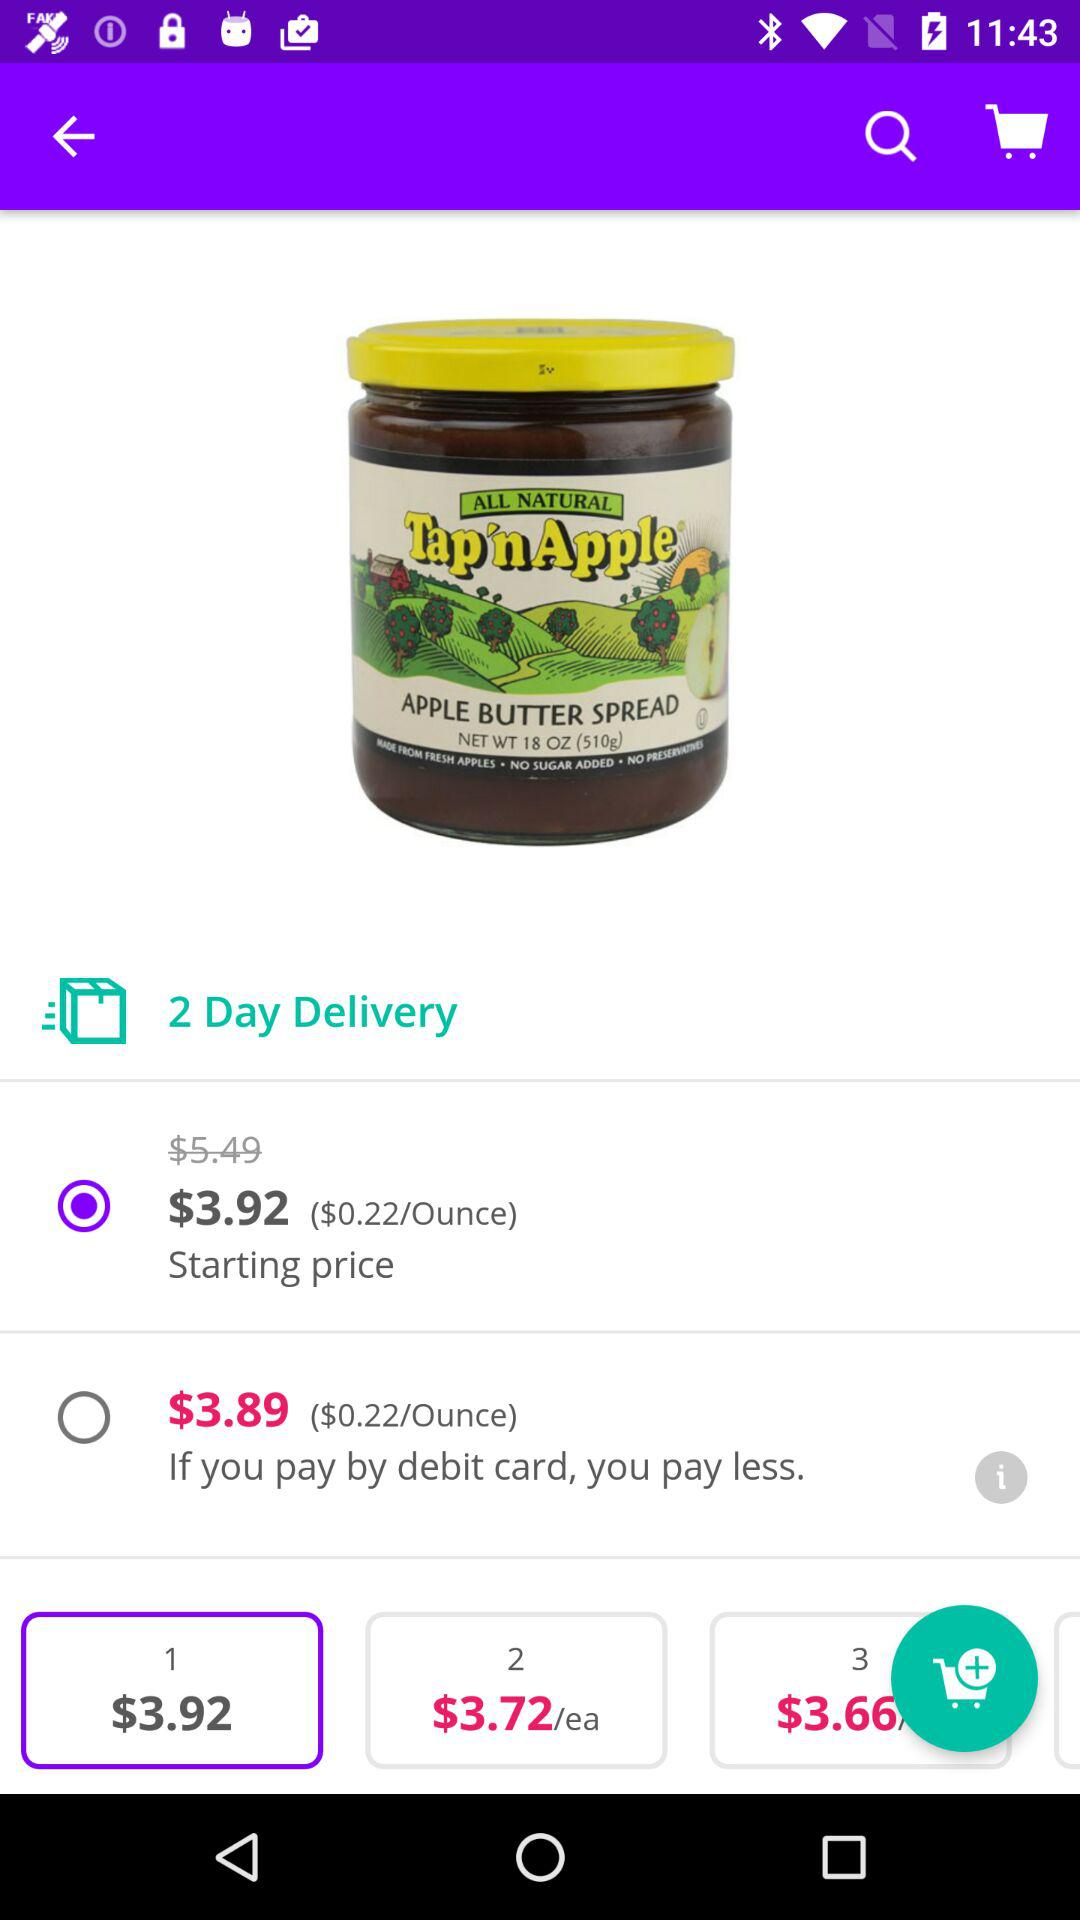Which option is selected for buying "APPLE BUTTER SPREAD"? The selected option is "$3.92". 